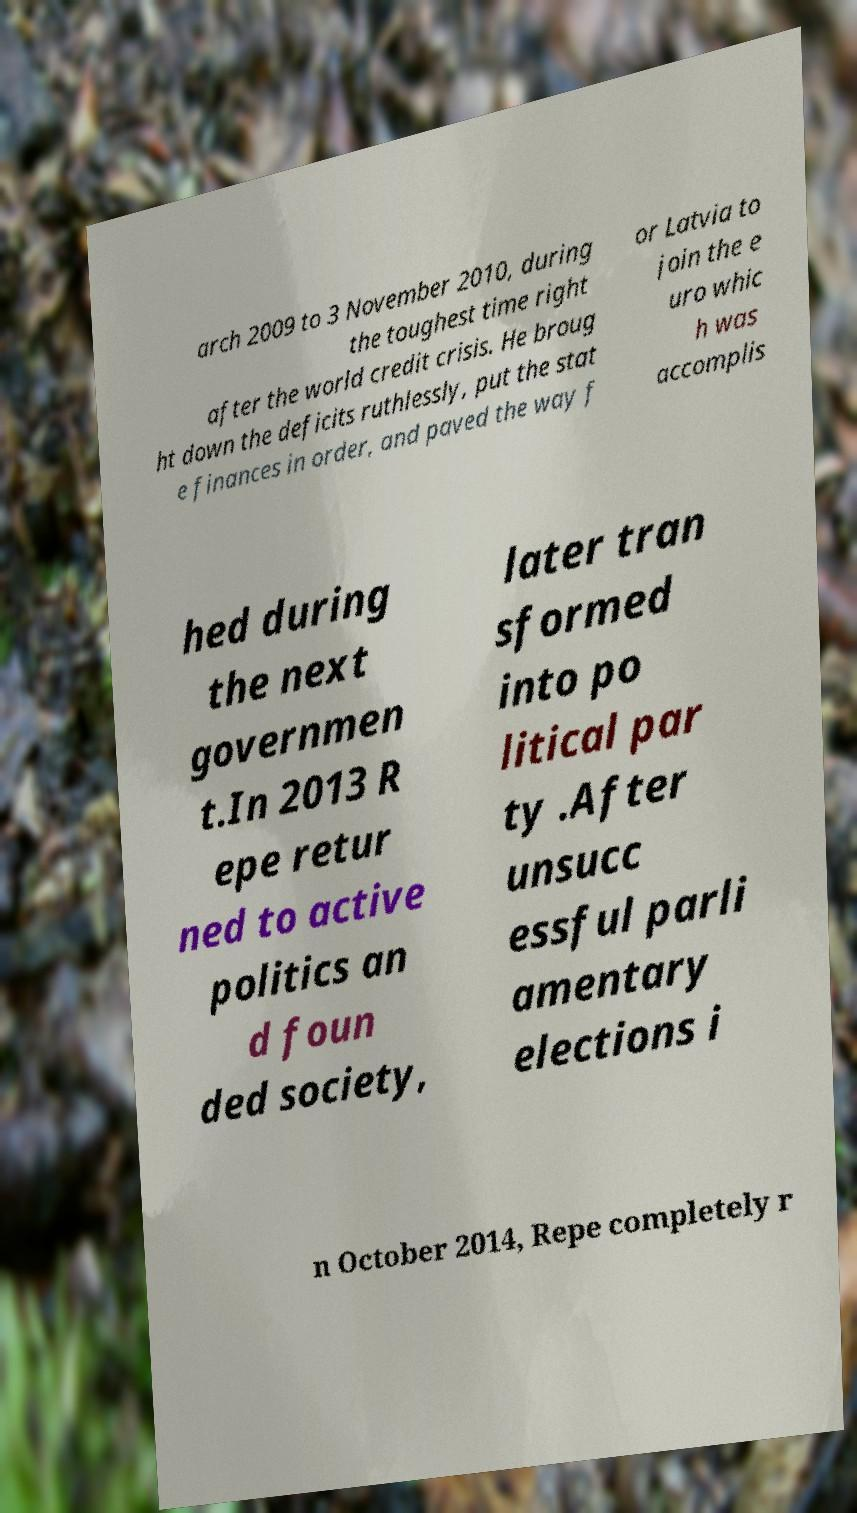I need the written content from this picture converted into text. Can you do that? arch 2009 to 3 November 2010, during the toughest time right after the world credit crisis. He broug ht down the deficits ruthlessly, put the stat e finances in order, and paved the way f or Latvia to join the e uro whic h was accomplis hed during the next governmen t.In 2013 R epe retur ned to active politics an d foun ded society, later tran sformed into po litical par ty .After unsucc essful parli amentary elections i n October 2014, Repe completely r 